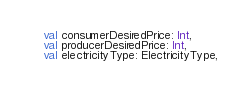Convert code to text. <code><loc_0><loc_0><loc_500><loc_500><_Kotlin_>    val consumerDesiredPrice: Int,
    val producerDesiredPrice: Int,
    val electricityType: ElectricityType,</code> 